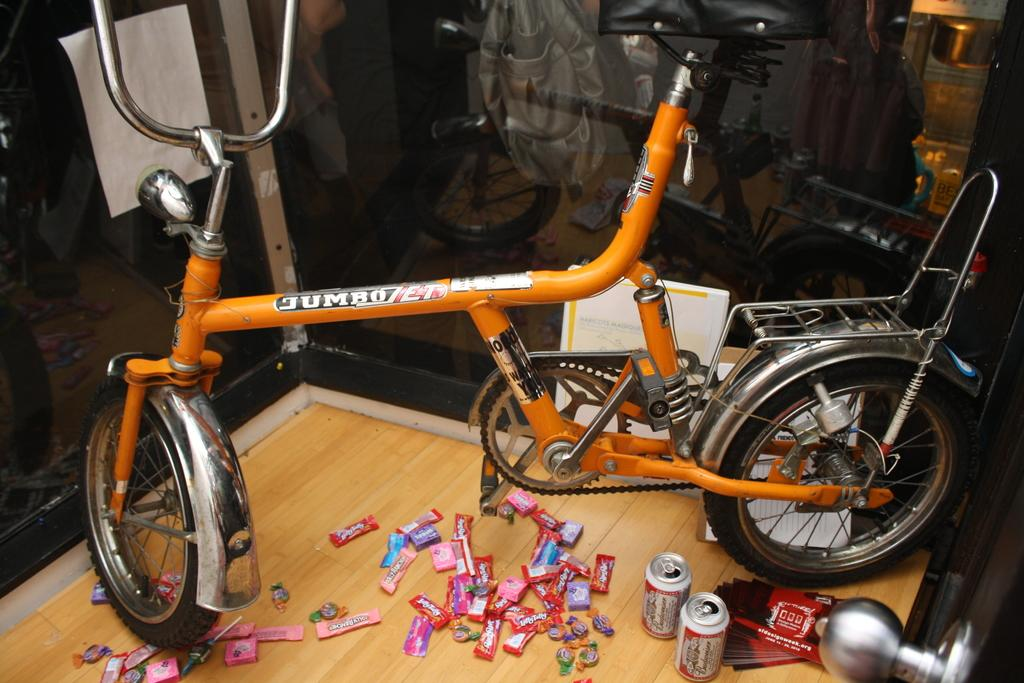What is the main object in the image? There is a bicycle in the image. What other items can be seen in the image? There are tins, chocolates, and a glass box containing other objects in the image. What is inside the glass box? The contents of the glass box are not specified in the facts, so we cannot answer that question definitively. What is the paper used for in the image? The purpose of the paper in the image is not specified in the facts, so we cannot answer that question definitively. What is the source of light in the image? The facts do not specify the source of light in the image, so we cannot answer that question definitively. Where is the kitty sitting in the image? There is no kitty present in the image. What scientific experiment is being conducted in the image? The facts do not mention any scientific experiment taking place in the image. What type of station is depicted in the image? The facts do not mention any station, such as a train station or bus station, in the image. 